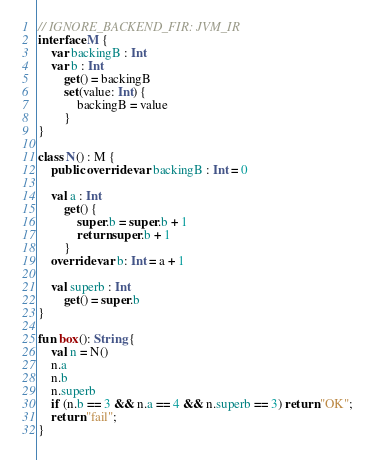<code> <loc_0><loc_0><loc_500><loc_500><_Kotlin_>// IGNORE_BACKEND_FIR: JVM_IR
interface M {
    var backingB : Int
    var b : Int
        get() = backingB
        set(value: Int) {
            backingB = value
        }
}

class N() : M {
    public override var backingB : Int = 0

    val a : Int
        get() {
            super.b = super.b + 1
            return super.b + 1
        }
    override var b: Int = a + 1

    val superb : Int
        get() = super.b
}

fun box(): String {
    val n = N()
    n.a
    n.b
    n.superb
    if (n.b == 3 && n.a == 4 && n.superb == 3) return "OK";
    return "fail";
}
</code> 